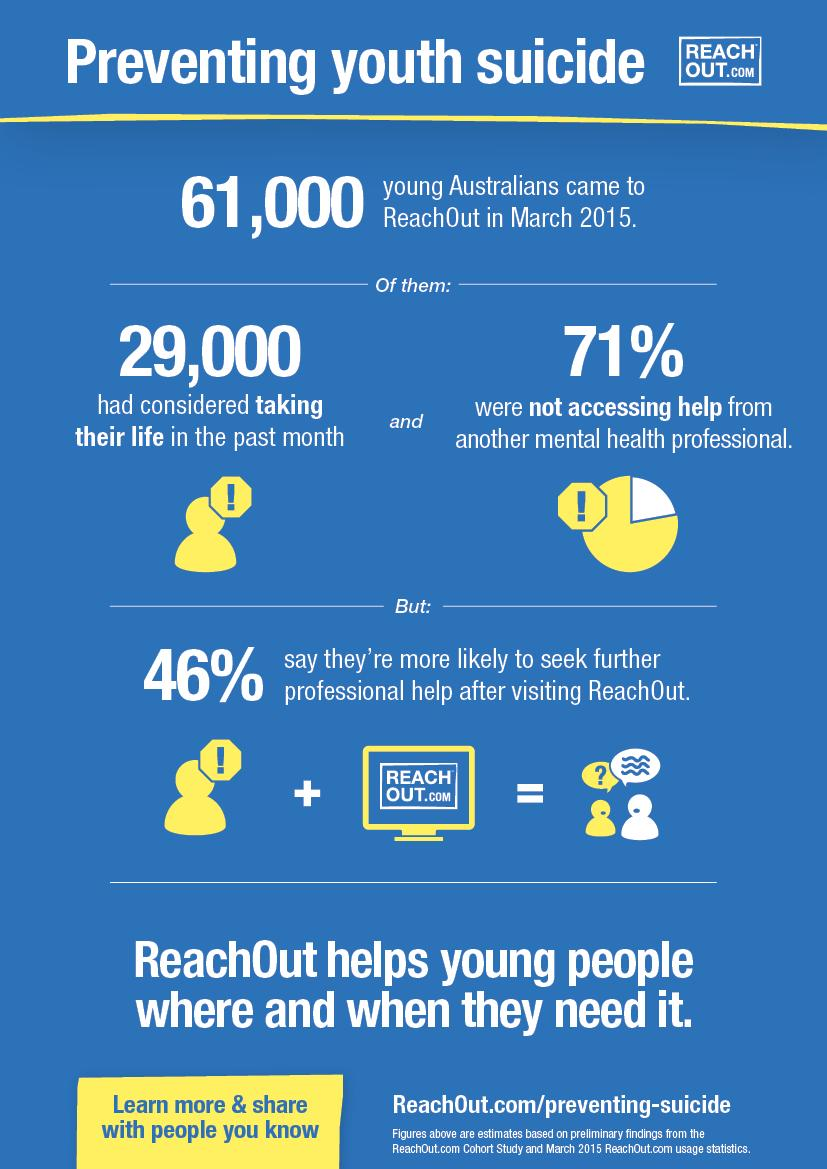Highlight a few significant elements in this photo. The image on a computer is written with the text REACHOUT.com. 